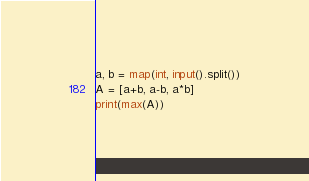Convert code to text. <code><loc_0><loc_0><loc_500><loc_500><_Python_>a, b = map(int, input().split())
A = [a+b, a-b, a*b]
print(max(A))</code> 